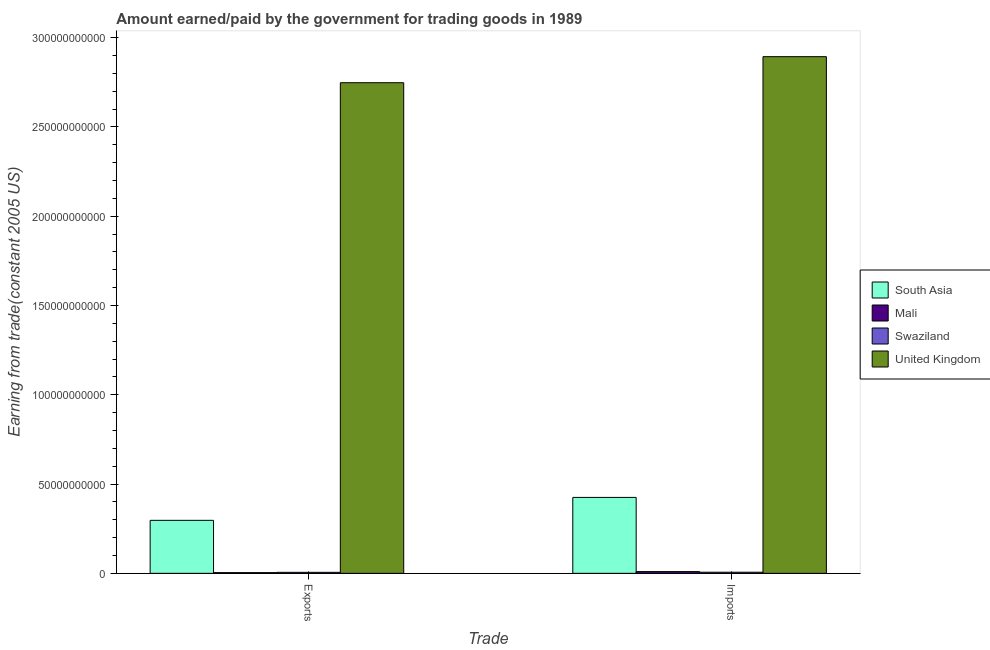How many different coloured bars are there?
Your answer should be compact. 4. How many groups of bars are there?
Your answer should be compact. 2. Are the number of bars per tick equal to the number of legend labels?
Your answer should be compact. Yes. How many bars are there on the 2nd tick from the right?
Ensure brevity in your answer.  4. What is the label of the 1st group of bars from the left?
Your answer should be compact. Exports. What is the amount earned from exports in United Kingdom?
Ensure brevity in your answer.  2.75e+11. Across all countries, what is the maximum amount earned from exports?
Your answer should be compact. 2.75e+11. Across all countries, what is the minimum amount earned from exports?
Make the answer very short. 3.92e+08. In which country was the amount earned from exports maximum?
Your response must be concise. United Kingdom. In which country was the amount earned from exports minimum?
Provide a succinct answer. Mali. What is the total amount earned from exports in the graph?
Ensure brevity in your answer.  3.05e+11. What is the difference between the amount earned from exports in Swaziland and that in United Kingdom?
Your answer should be compact. -2.74e+11. What is the difference between the amount paid for imports in Swaziland and the amount earned from exports in South Asia?
Offer a terse response. -2.91e+1. What is the average amount earned from exports per country?
Make the answer very short. 7.63e+1. What is the difference between the amount earned from exports and amount paid for imports in South Asia?
Ensure brevity in your answer.  -1.28e+1. In how many countries, is the amount paid for imports greater than 50000000000 US$?
Offer a very short reply. 1. What is the ratio of the amount earned from exports in United Kingdom to that in South Asia?
Provide a short and direct response. 9.26. What does the 3rd bar from the left in Imports represents?
Give a very brief answer. Swaziland. What does the 1st bar from the right in Imports represents?
Your response must be concise. United Kingdom. How many countries are there in the graph?
Keep it short and to the point. 4. Are the values on the major ticks of Y-axis written in scientific E-notation?
Offer a very short reply. No. Does the graph contain grids?
Provide a short and direct response. No. Where does the legend appear in the graph?
Your answer should be very brief. Center right. How many legend labels are there?
Keep it short and to the point. 4. How are the legend labels stacked?
Offer a terse response. Vertical. What is the title of the graph?
Your answer should be compact. Amount earned/paid by the government for trading goods in 1989. What is the label or title of the X-axis?
Provide a short and direct response. Trade. What is the label or title of the Y-axis?
Your answer should be very brief. Earning from trade(constant 2005 US). What is the Earning from trade(constant 2005 US) of South Asia in Exports?
Provide a short and direct response. 2.97e+1. What is the Earning from trade(constant 2005 US) of Mali in Exports?
Your answer should be very brief. 3.92e+08. What is the Earning from trade(constant 2005 US) in Swaziland in Exports?
Provide a succinct answer. 5.57e+08. What is the Earning from trade(constant 2005 US) of United Kingdom in Exports?
Keep it short and to the point. 2.75e+11. What is the Earning from trade(constant 2005 US) in South Asia in Imports?
Offer a terse response. 4.25e+1. What is the Earning from trade(constant 2005 US) in Mali in Imports?
Keep it short and to the point. 9.73e+08. What is the Earning from trade(constant 2005 US) in Swaziland in Imports?
Your response must be concise. 6.19e+08. What is the Earning from trade(constant 2005 US) of United Kingdom in Imports?
Your answer should be compact. 2.89e+11. Across all Trade, what is the maximum Earning from trade(constant 2005 US) of South Asia?
Make the answer very short. 4.25e+1. Across all Trade, what is the maximum Earning from trade(constant 2005 US) of Mali?
Make the answer very short. 9.73e+08. Across all Trade, what is the maximum Earning from trade(constant 2005 US) in Swaziland?
Provide a short and direct response. 6.19e+08. Across all Trade, what is the maximum Earning from trade(constant 2005 US) in United Kingdom?
Give a very brief answer. 2.89e+11. Across all Trade, what is the minimum Earning from trade(constant 2005 US) in South Asia?
Your answer should be compact. 2.97e+1. Across all Trade, what is the minimum Earning from trade(constant 2005 US) of Mali?
Give a very brief answer. 3.92e+08. Across all Trade, what is the minimum Earning from trade(constant 2005 US) in Swaziland?
Offer a very short reply. 5.57e+08. Across all Trade, what is the minimum Earning from trade(constant 2005 US) in United Kingdom?
Keep it short and to the point. 2.75e+11. What is the total Earning from trade(constant 2005 US) in South Asia in the graph?
Make the answer very short. 7.22e+1. What is the total Earning from trade(constant 2005 US) in Mali in the graph?
Offer a very short reply. 1.36e+09. What is the total Earning from trade(constant 2005 US) of Swaziland in the graph?
Your answer should be very brief. 1.18e+09. What is the total Earning from trade(constant 2005 US) in United Kingdom in the graph?
Keep it short and to the point. 5.64e+11. What is the difference between the Earning from trade(constant 2005 US) in South Asia in Exports and that in Imports?
Provide a succinct answer. -1.28e+1. What is the difference between the Earning from trade(constant 2005 US) in Mali in Exports and that in Imports?
Offer a terse response. -5.80e+08. What is the difference between the Earning from trade(constant 2005 US) of Swaziland in Exports and that in Imports?
Keep it short and to the point. -6.20e+07. What is the difference between the Earning from trade(constant 2005 US) of United Kingdom in Exports and that in Imports?
Your answer should be very brief. -1.46e+1. What is the difference between the Earning from trade(constant 2005 US) in South Asia in Exports and the Earning from trade(constant 2005 US) in Mali in Imports?
Offer a terse response. 2.87e+1. What is the difference between the Earning from trade(constant 2005 US) of South Asia in Exports and the Earning from trade(constant 2005 US) of Swaziland in Imports?
Offer a very short reply. 2.91e+1. What is the difference between the Earning from trade(constant 2005 US) in South Asia in Exports and the Earning from trade(constant 2005 US) in United Kingdom in Imports?
Offer a very short reply. -2.60e+11. What is the difference between the Earning from trade(constant 2005 US) of Mali in Exports and the Earning from trade(constant 2005 US) of Swaziland in Imports?
Provide a short and direct response. -2.26e+08. What is the difference between the Earning from trade(constant 2005 US) of Mali in Exports and the Earning from trade(constant 2005 US) of United Kingdom in Imports?
Your answer should be compact. -2.89e+11. What is the difference between the Earning from trade(constant 2005 US) in Swaziland in Exports and the Earning from trade(constant 2005 US) in United Kingdom in Imports?
Your answer should be very brief. -2.89e+11. What is the average Earning from trade(constant 2005 US) of South Asia per Trade?
Your answer should be very brief. 3.61e+1. What is the average Earning from trade(constant 2005 US) of Mali per Trade?
Keep it short and to the point. 6.82e+08. What is the average Earning from trade(constant 2005 US) in Swaziland per Trade?
Your answer should be very brief. 5.88e+08. What is the average Earning from trade(constant 2005 US) in United Kingdom per Trade?
Your answer should be very brief. 2.82e+11. What is the difference between the Earning from trade(constant 2005 US) in South Asia and Earning from trade(constant 2005 US) in Mali in Exports?
Provide a short and direct response. 2.93e+1. What is the difference between the Earning from trade(constant 2005 US) of South Asia and Earning from trade(constant 2005 US) of Swaziland in Exports?
Ensure brevity in your answer.  2.91e+1. What is the difference between the Earning from trade(constant 2005 US) in South Asia and Earning from trade(constant 2005 US) in United Kingdom in Exports?
Keep it short and to the point. -2.45e+11. What is the difference between the Earning from trade(constant 2005 US) in Mali and Earning from trade(constant 2005 US) in Swaziland in Exports?
Your answer should be very brief. -1.64e+08. What is the difference between the Earning from trade(constant 2005 US) of Mali and Earning from trade(constant 2005 US) of United Kingdom in Exports?
Ensure brevity in your answer.  -2.74e+11. What is the difference between the Earning from trade(constant 2005 US) in Swaziland and Earning from trade(constant 2005 US) in United Kingdom in Exports?
Your answer should be very brief. -2.74e+11. What is the difference between the Earning from trade(constant 2005 US) of South Asia and Earning from trade(constant 2005 US) of Mali in Imports?
Give a very brief answer. 4.15e+1. What is the difference between the Earning from trade(constant 2005 US) of South Asia and Earning from trade(constant 2005 US) of Swaziland in Imports?
Your answer should be very brief. 4.19e+1. What is the difference between the Earning from trade(constant 2005 US) of South Asia and Earning from trade(constant 2005 US) of United Kingdom in Imports?
Offer a terse response. -2.47e+11. What is the difference between the Earning from trade(constant 2005 US) of Mali and Earning from trade(constant 2005 US) of Swaziland in Imports?
Your answer should be compact. 3.54e+08. What is the difference between the Earning from trade(constant 2005 US) of Mali and Earning from trade(constant 2005 US) of United Kingdom in Imports?
Your answer should be very brief. -2.88e+11. What is the difference between the Earning from trade(constant 2005 US) of Swaziland and Earning from trade(constant 2005 US) of United Kingdom in Imports?
Your answer should be very brief. -2.89e+11. What is the ratio of the Earning from trade(constant 2005 US) of South Asia in Exports to that in Imports?
Offer a terse response. 0.7. What is the ratio of the Earning from trade(constant 2005 US) of Mali in Exports to that in Imports?
Make the answer very short. 0.4. What is the ratio of the Earning from trade(constant 2005 US) in Swaziland in Exports to that in Imports?
Offer a very short reply. 0.9. What is the ratio of the Earning from trade(constant 2005 US) in United Kingdom in Exports to that in Imports?
Ensure brevity in your answer.  0.95. What is the difference between the highest and the second highest Earning from trade(constant 2005 US) of South Asia?
Your response must be concise. 1.28e+1. What is the difference between the highest and the second highest Earning from trade(constant 2005 US) in Mali?
Your answer should be very brief. 5.80e+08. What is the difference between the highest and the second highest Earning from trade(constant 2005 US) of Swaziland?
Provide a short and direct response. 6.20e+07. What is the difference between the highest and the second highest Earning from trade(constant 2005 US) in United Kingdom?
Make the answer very short. 1.46e+1. What is the difference between the highest and the lowest Earning from trade(constant 2005 US) of South Asia?
Your response must be concise. 1.28e+1. What is the difference between the highest and the lowest Earning from trade(constant 2005 US) of Mali?
Your response must be concise. 5.80e+08. What is the difference between the highest and the lowest Earning from trade(constant 2005 US) of Swaziland?
Your answer should be very brief. 6.20e+07. What is the difference between the highest and the lowest Earning from trade(constant 2005 US) of United Kingdom?
Offer a terse response. 1.46e+1. 